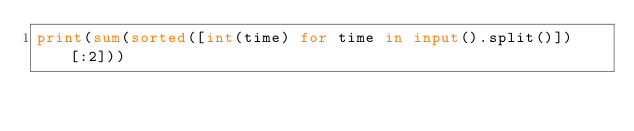Convert code to text. <code><loc_0><loc_0><loc_500><loc_500><_Python_>print(sum(sorted([int(time) for time in input().split()])[:2]))</code> 